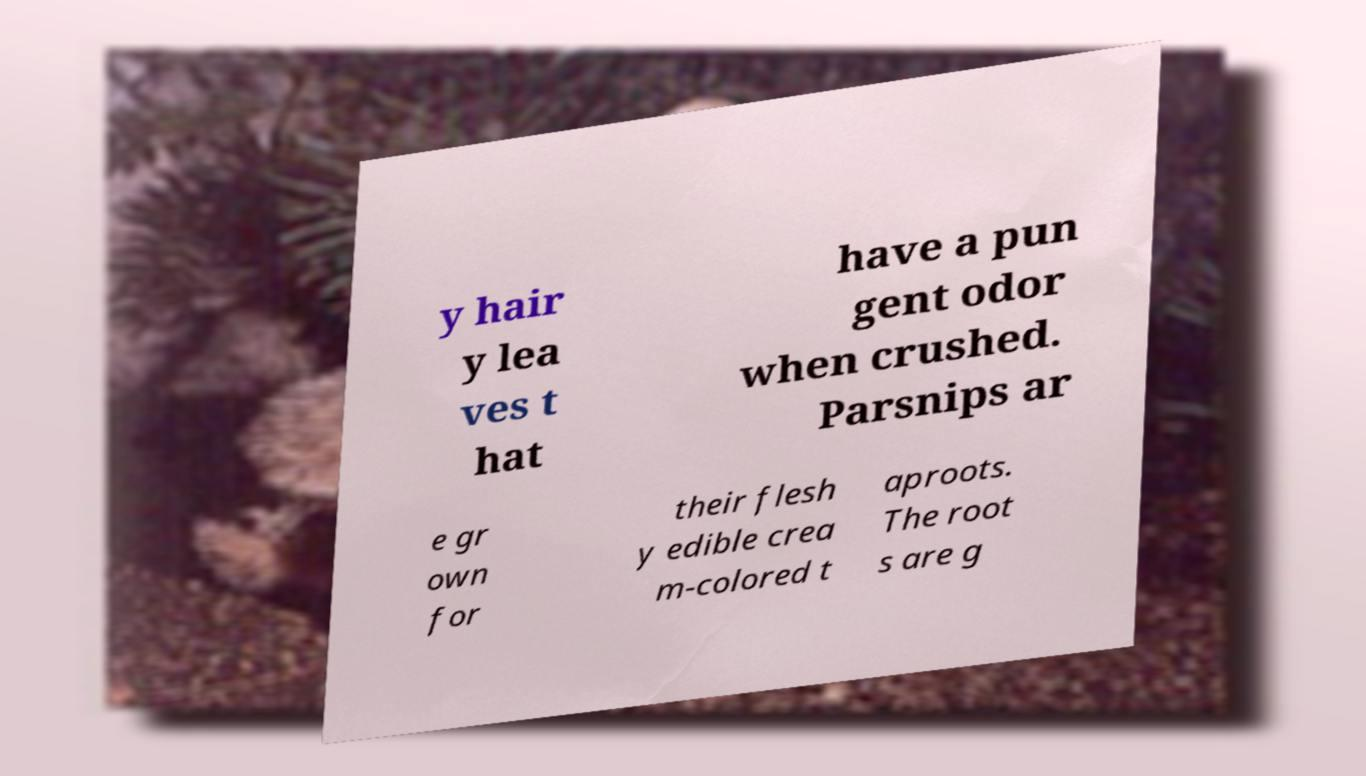What messages or text are displayed in this image? I need them in a readable, typed format. y hair y lea ves t hat have a pun gent odor when crushed. Parsnips ar e gr own for their flesh y edible crea m-colored t aproots. The root s are g 